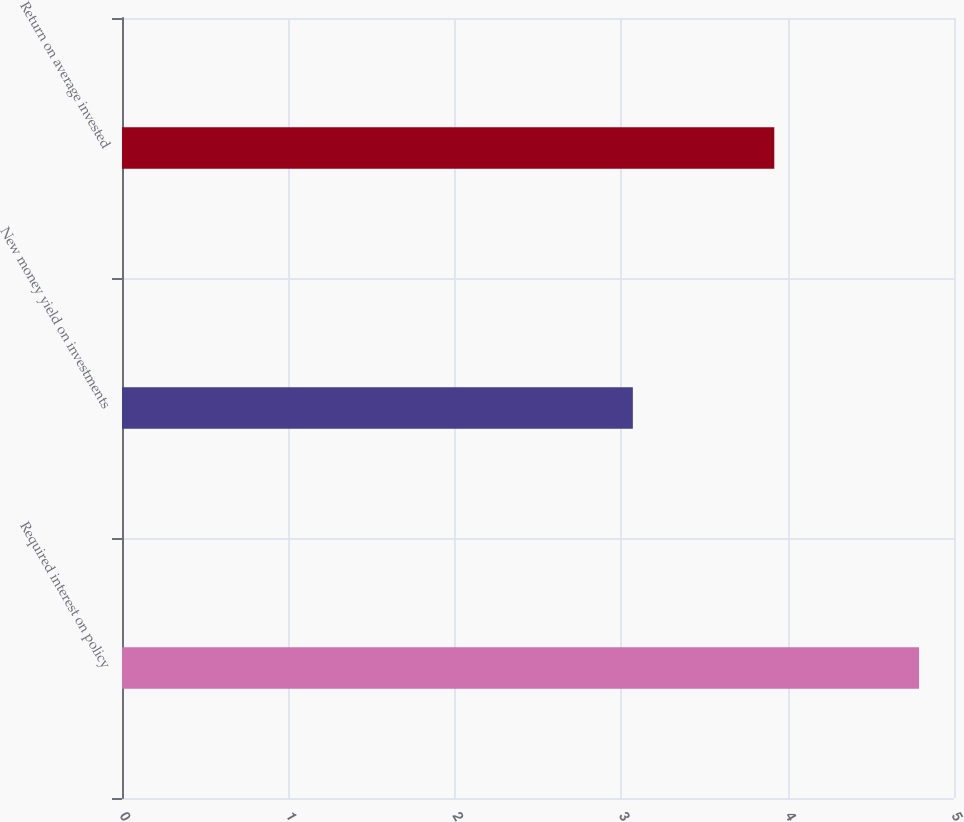<chart> <loc_0><loc_0><loc_500><loc_500><bar_chart><fcel>Required interest on policy<fcel>New money yield on investments<fcel>Return on average invested<nl><fcel>4.79<fcel>3.07<fcel>3.92<nl></chart> 